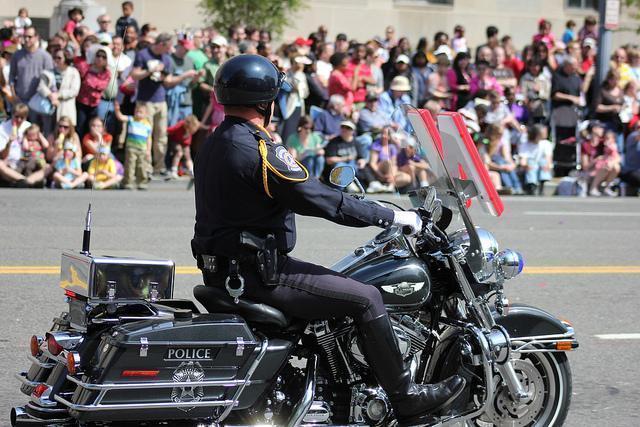What are the people on the street side focused on?
Indicate the correct response by choosing from the four available options to answer the question.
Options: Snacks, arrest, sirens, parade. Parade. 